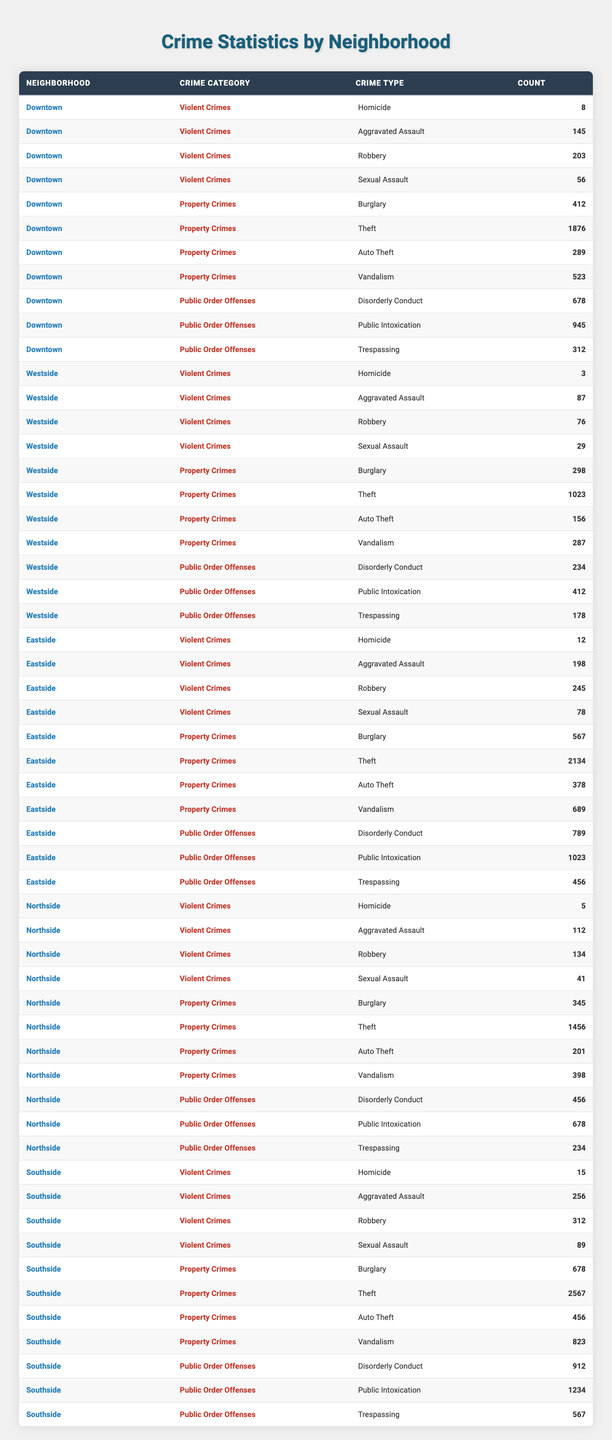What is the total number of Violent Crimes in Downtown? To find the total number of Violent Crimes in Downtown, we need to sum the counts of Homicide (8), Aggravated Assault (145), Robbery (203), and Sexual Assault (56). The calculation is: 8 + 145 + 203 + 56 = 412.
Answer: 412 Which neighborhood has the highest count of Theft? Upon examining the table, Eastside shows the highest count of Theft at 2134.
Answer: Eastside What is the total number of Public Order Offenses in the Southside? We sum the counts of Disorderly Conduct (912), Public Intoxication (1234), and Trespassing (567) in the Southside. The calculation is: 912 + 1234 + 567 = 2713.
Answer: 2713 Is the number of Robberies in Northside less than the number of Aggravated Assaults in Westside? Northside has 134 Robberies and Westside has 87 Aggravated Assaults. Since 134 is greater than 87, the statement is false.
Answer: No Which neighborhood experiences the most Homicides overall? The Homicide counts are Downtown (8), Westside (3), Eastside (12), Northside (5), and Southside (15). The maximum is in Southside with 15 Homicides.
Answer: Southside What is the difference in the count of Burglary between Eastside and Westside? Eastside has 567 Burglary cases and Westside has 298. The difference is calculated as: 567 - 298 = 269.
Answer: 269 What is the average number of Auto Thefts across all neighborhoods? The total Auto Theft counts are: Downtown (289), Westside (156), Eastside (378), Northside (201), and Southside (456). The total is 289 + 156 + 378 + 201 + 456 = 1480. With 5 neighborhoods, the average is 1480/5 = 296.
Answer: 296 Which neighborhood has the least number of Disorderly Conduct offenses? Examining the table, we see Disorderly Conduct counts: Downtown (678), Westside (234), Eastside (789), Northside (456), and Southside (912). Westside has the least count at 234.
Answer: Westside What proportion of total Property Crimes in Downtown are Burglary? The total Property Crimes in Downtown are Burglary (412), Theft (1876), Auto Theft (289), and Vandalism (523). The total is 412 + 1876 + 289 + 523 = 3100. The proportion of Burglary is 412 / 3100 = 0.1323.
Answer: 0.1323 Compare the total number of Violent Crimes between Eastside and Southside. Eastside has 12 Homicides, 198 Aggravated Assaults, 245 Robberies, and 78 Sexual Assaults (total: 12 + 198 + 245 + 78 = 533). Southside has 15 Homicides, 256 Aggravated Assaults, 312 Robberies, and 89 Sexual Assaults (total: 15 + 256 + 312 + 89 = 672). Southside has more Violent Crimes than Eastside.
Answer: Southside 